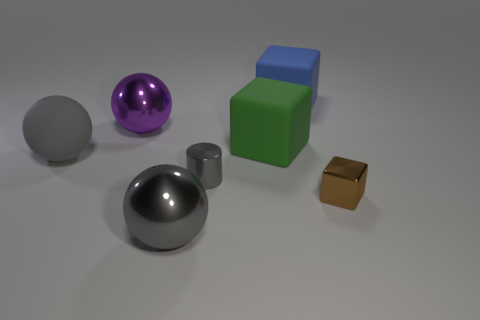There is a rubber thing that is the same color as the tiny cylinder; what is its shape?
Your answer should be compact. Sphere. Do the cube behind the large purple metallic sphere and the brown cube have the same material?
Provide a succinct answer. No. There is a purple metal object; what shape is it?
Provide a short and direct response. Sphere. How many gray objects are either big blocks or shiny balls?
Provide a succinct answer. 1. What number of other objects are the same material as the gray cylinder?
Provide a short and direct response. 3. There is a metal thing that is behind the big gray rubber object; does it have the same shape as the large gray metallic object?
Your answer should be very brief. Yes. Are any small blue matte cylinders visible?
Give a very brief answer. No. Is there anything else that is the same shape as the small gray thing?
Your response must be concise. No. Are there more large things that are behind the gray metal ball than shiny objects?
Provide a succinct answer. No. Are there any large matte cubes to the right of the big green matte object?
Offer a terse response. Yes. 